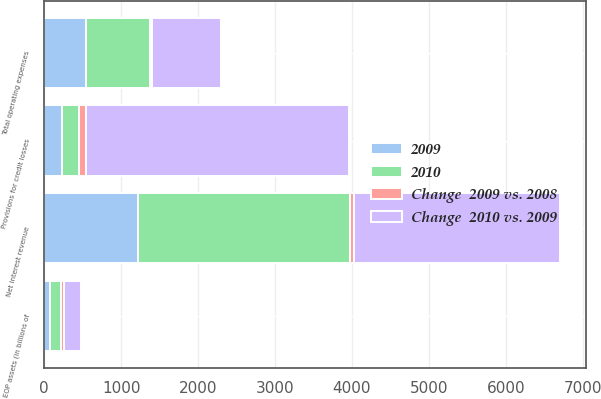Convert chart to OTSL. <chart><loc_0><loc_0><loc_500><loc_500><stacked_bar_chart><ecel><fcel>Net interest revenue<fcel>Total operating expenses<fcel>Provisions for credit losses<fcel>EOP assets (in billions of<nl><fcel>2009<fcel>1219<fcel>548<fcel>226<fcel>80<nl><fcel>2010<fcel>2754<fcel>824<fcel>226<fcel>136<nl><fcel>Change  2010 vs. 2009<fcel>2676<fcel>893<fcel>3411<fcel>219<nl><fcel>Change  2009 vs. 2008<fcel>56<fcel>33<fcel>95<fcel>41<nl></chart> 